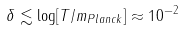<formula> <loc_0><loc_0><loc_500><loc_500>\delta \lesssim \log [ T / m _ { P l a n c k } ] \approx 1 0 ^ { - 2 }</formula> 